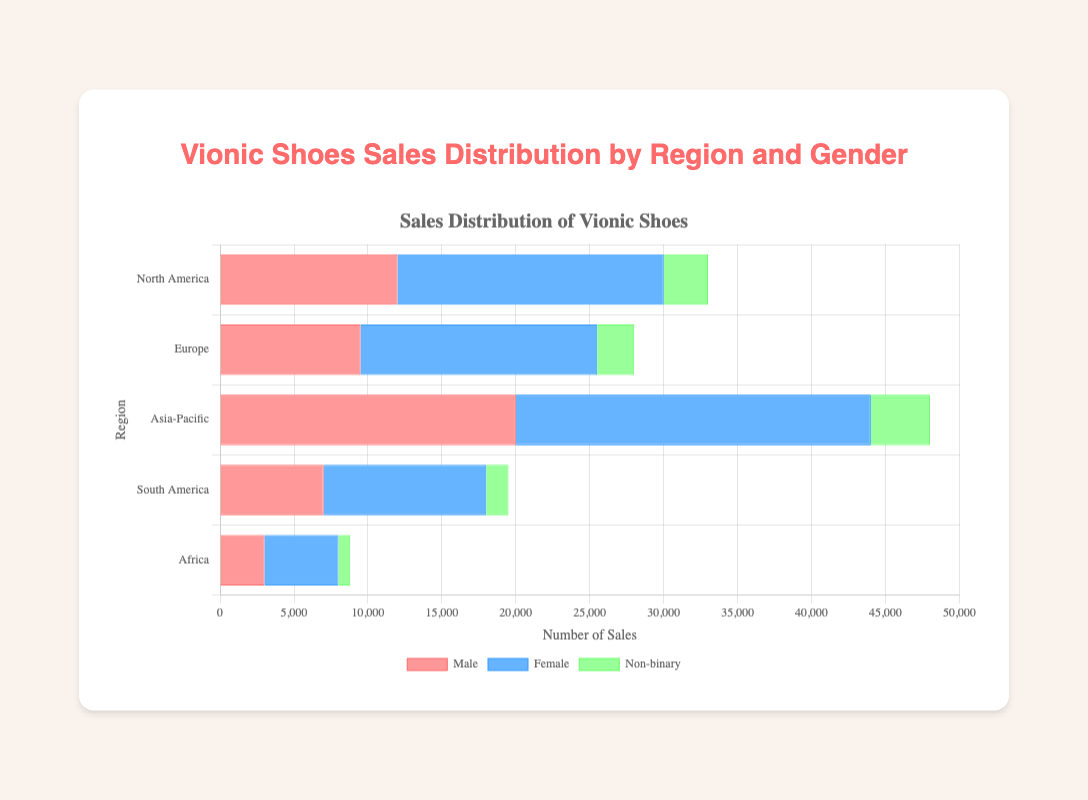Which region has the highest sales for Female Vionic shoes? To find the region with the highest sales for Female Vionic shoes, look for the longest bar in the Female category. In this case, the bar for "Asia-Pacific" is the longest.
Answer: Asia-Pacific What is the total sales of Vionic shoes in North America across all genders? Add up the sales for Male, Female, and Non-binary in North America: 12000 (Male) + 18000 (Female) + 3000 (Non-binary) = 33000.
Answer: 33000 Which gender has the lowest sales in Africa? Compare the bars for Male, Female, and Non-binary in Africa. The shortest bar represents the lowest sales, which is for "Non-binary".
Answer: Non-binary What is the average sales of Vionic shoes for Non-binary category across all regions? To calculate the average, sum up the Non-binary sales for all regions and divide by the number of regions: (3000 + 2500 + 4000 + 1500 + 800) / 5 = 11800 / 5 = 2360.
Answer: 2360 Compare the sales of Vionic shoes for Male and Female in South America. Which is higher and by how much? In South America, Male sales are 7000, and Female sales are 11000. The difference is 11000 - 7000 = 4000, with Female sales being higher.
Answer: Female by 4000 What is the combined sales of Vionic shoes in Europe and South America for the Non-binary category? Add the Non-binary sales for Europe and South America: 2500 (Europe) + 1500 (South America) = 4000.
Answer: 4000 How do the sales of Vionic shoes in Africa compare between Male and Female categories? In Africa, Male sales are 3000, and Female sales are 5000. Since 5000 > 3000, Female sales are higher.
Answer: Female sales are higher What is the difference in total sales between the region with the highest overall sales and the region with the lowest overall sales? The highest total sales is in Asia-Pacific: 20000 (Male) + 24000 (Female) + 4000 (Non-binary) = 48000. The lowest total sales is in Africa: 3000 (Male) + 5000 (Female) + 800 (Non-binary) = 8800. The difference is 48000 - 8800 = 39200.
Answer: 39200 What's the total sales for the Female category in all regions combined? Sum the Female sales across all regions: 18000 (North America) + 16000 (Europe) + 24000 (Asia-Pacific) + 11000 (South America) + 5000 (Africa) = 74000.
Answer: 74000 